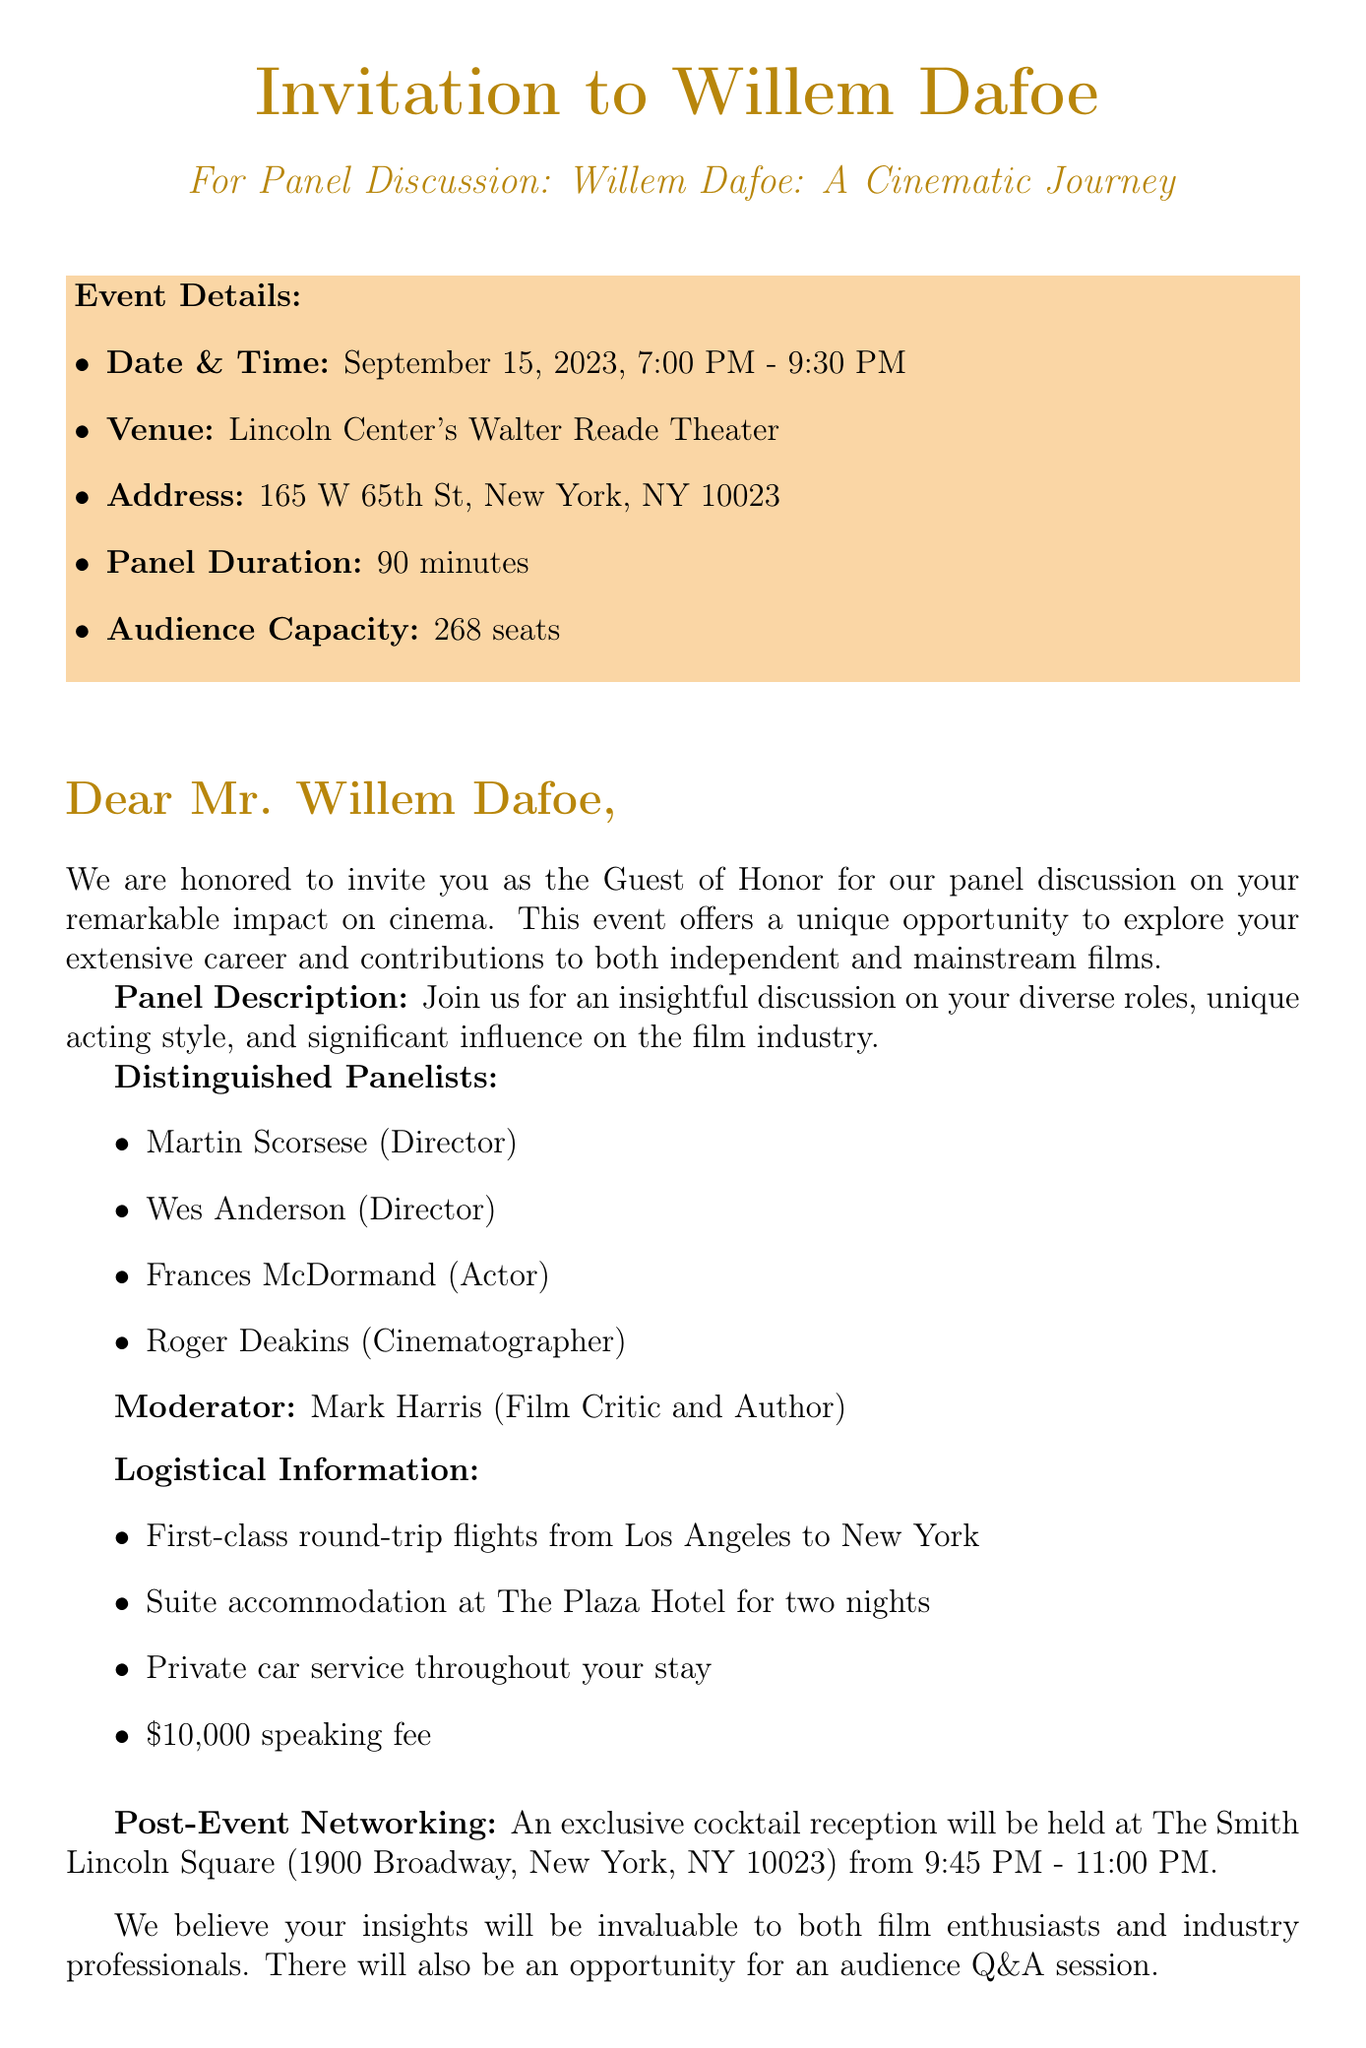What is the event name? The event name is clearly stated at the beginning of the document.
Answer: Willem Dafoe: A Cinematic Journey What is the date of the event? The date of the event is mentioned in the event details section.
Answer: September 15, 2023 What is the venue for the discussion? The venue is specified as the location where the event will take place.
Answer: Lincoln Center's Walter Reade Theater Who is the moderator for the panel? The document lists the moderator in a specific section.
Answer: Mark Harris (Film Critic and Author) How long will the panel discussion last? The duration of the panel is indicated in the event details.
Answer: 90 minutes What is the honorarium offered to Willem Dafoe? The speaking fee is outlined in the logistical information section.
Answer: $10,000 What time does the post-event networking reception start? The time for the reception is provided in the post-event networking section.
Answer: 9:45 PM Who are two distinguished panelists joining the discussion? The document lists panelists under a specific heading, from which any two can be selected.
Answer: Martin Scorsese, Wes Anderson Why is Willem Dafoe considered the guest of honor? This is implied in the invitation key points highlighting the significance of his presence.
Answer: Unique opportunity to discuss his extensive career 